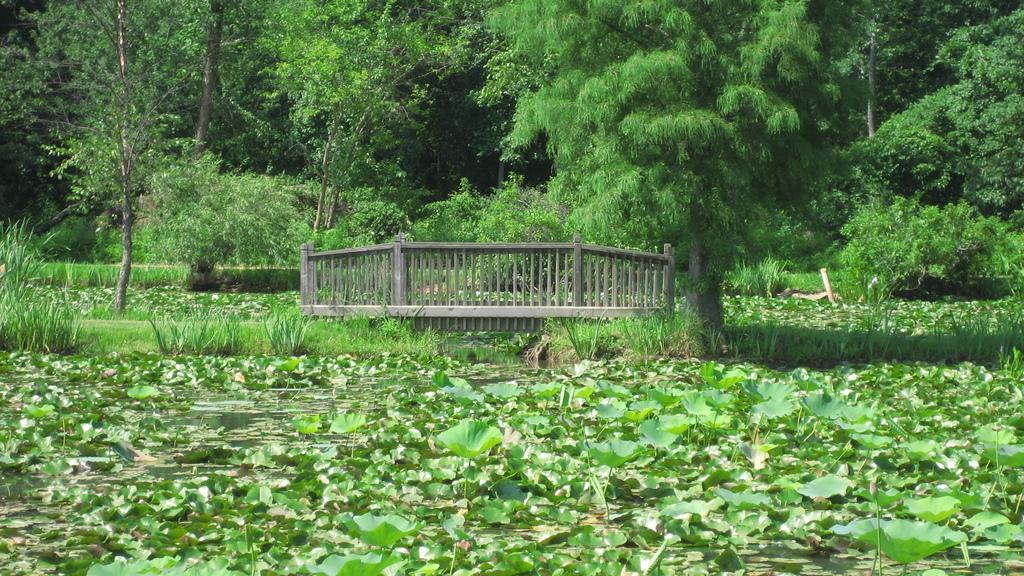Please provide a concise description of this image. There are plants on the water in the foreground area of the image, it seems like a dock and trees in the background. 